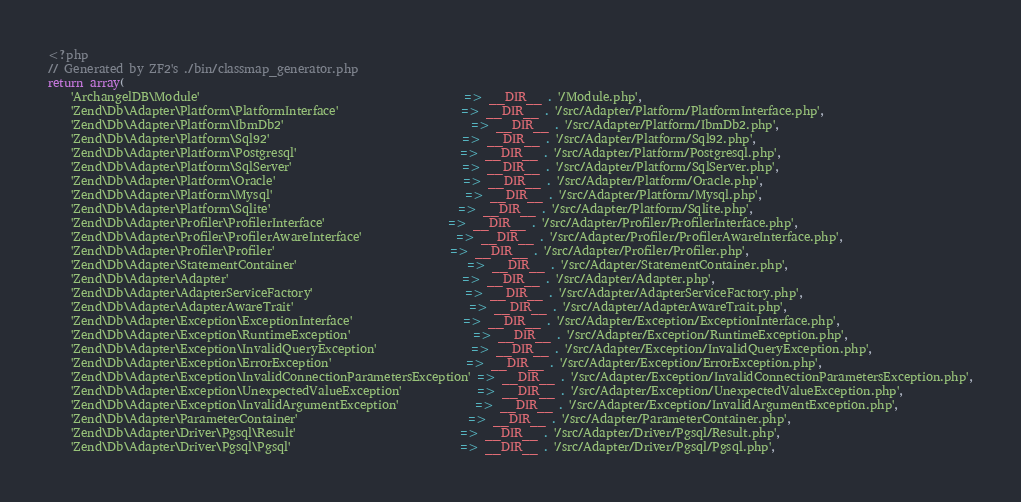Convert code to text. <code><loc_0><loc_0><loc_500><loc_500><_PHP_><?php
// Generated by ZF2's ./bin/classmap_generator.php
return array(
    'ArchangelDB\Module'                                             => __DIR__ . '/Module.php',
    'Zend\Db\Adapter\Platform\PlatformInterface'                     => __DIR__ . '/src/Adapter/Platform/PlatformInterface.php',
    'Zend\Db\Adapter\Platform\IbmDb2'                                => __DIR__ . '/src/Adapter/Platform/IbmDb2.php',
    'Zend\Db\Adapter\Platform\Sql92'                                 => __DIR__ . '/src/Adapter/Platform/Sql92.php',
    'Zend\Db\Adapter\Platform\Postgresql'                            => __DIR__ . '/src/Adapter/Platform/Postgresql.php',
    'Zend\Db\Adapter\Platform\SqlServer'                             => __DIR__ . '/src/Adapter/Platform/SqlServer.php',
    'Zend\Db\Adapter\Platform\Oracle'                                => __DIR__ . '/src/Adapter/Platform/Oracle.php',
    'Zend\Db\Adapter\Platform\Mysql'                                 => __DIR__ . '/src/Adapter/Platform/Mysql.php',
    'Zend\Db\Adapter\Platform\Sqlite'                                => __DIR__ . '/src/Adapter/Platform/Sqlite.php',
    'Zend\Db\Adapter\Profiler\ProfilerInterface'                     => __DIR__ . '/src/Adapter/Profiler/ProfilerInterface.php',
    'Zend\Db\Adapter\Profiler\ProfilerAwareInterface'                => __DIR__ . '/src/Adapter/Profiler/ProfilerAwareInterface.php',
    'Zend\Db\Adapter\Profiler\Profiler'                              => __DIR__ . '/src/Adapter/Profiler/Profiler.php',
    'Zend\Db\Adapter\StatementContainer'                             => __DIR__ . '/src/Adapter/StatementContainer.php',
    'Zend\Db\Adapter\Adapter'                                        => __DIR__ . '/src/Adapter/Adapter.php',
    'Zend\Db\Adapter\AdapterServiceFactory'                          => __DIR__ . '/src/Adapter/AdapterServiceFactory.php',
    'Zend\Db\Adapter\AdapterAwareTrait'                              => __DIR__ . '/src/Adapter/AdapterAwareTrait.php',
    'Zend\Db\Adapter\Exception\ExceptionInterface'                   => __DIR__ . '/src/Adapter/Exception/ExceptionInterface.php',
    'Zend\Db\Adapter\Exception\RuntimeException'                     => __DIR__ . '/src/Adapter/Exception/RuntimeException.php',
    'Zend\Db\Adapter\Exception\InvalidQueryException'                => __DIR__ . '/src/Adapter/Exception/InvalidQueryException.php',
    'Zend\Db\Adapter\Exception\ErrorException'                       => __DIR__ . '/src/Adapter/Exception/ErrorException.php',
    'Zend\Db\Adapter\Exception\InvalidConnectionParametersException' => __DIR__ . '/src/Adapter/Exception/InvalidConnectionParametersException.php',
    'Zend\Db\Adapter\Exception\UnexpectedValueException'             => __DIR__ . '/src/Adapter/Exception/UnexpectedValueException.php',
    'Zend\Db\Adapter\Exception\InvalidArgumentException'             => __DIR__ . '/src/Adapter/Exception/InvalidArgumentException.php',
    'Zend\Db\Adapter\ParameterContainer'                             => __DIR__ . '/src/Adapter/ParameterContainer.php',
    'Zend\Db\Adapter\Driver\Pgsql\Result'                            => __DIR__ . '/src/Adapter/Driver/Pgsql/Result.php',
    'Zend\Db\Adapter\Driver\Pgsql\Pgsql'                             => __DIR__ . '/src/Adapter/Driver/Pgsql/Pgsql.php',</code> 